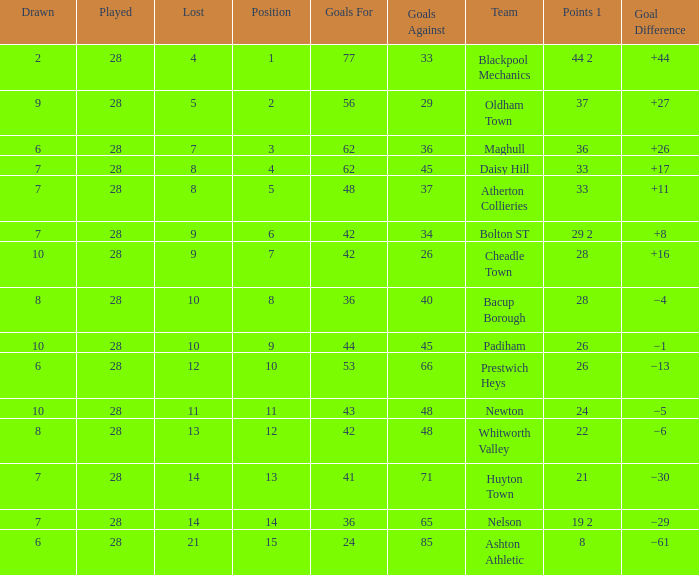For entries with fewer than 28 played, with 45 goals against and points 1 of 33, what is the average drawn? None. 